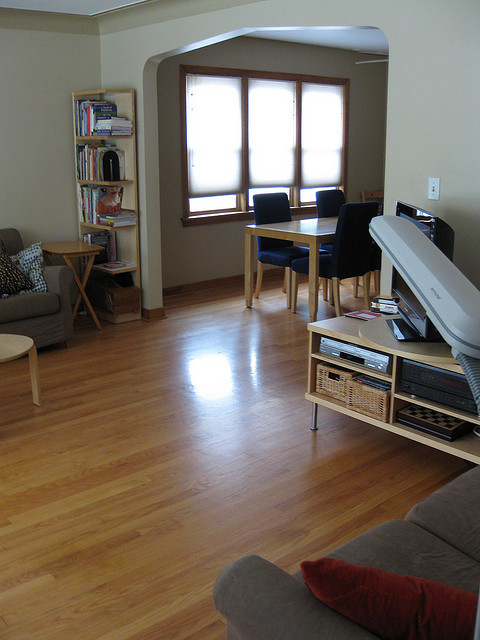<image>Why did this picture only capture the side of the room? It is unknown why the picture only captured the side of the room. However, it might be because of the camera angle or where the person was standing. Why did this picture only capture the side of the room? I don't know why this picture only captured the side of the room. It could be due to the angle or the photographer planned it that way. 